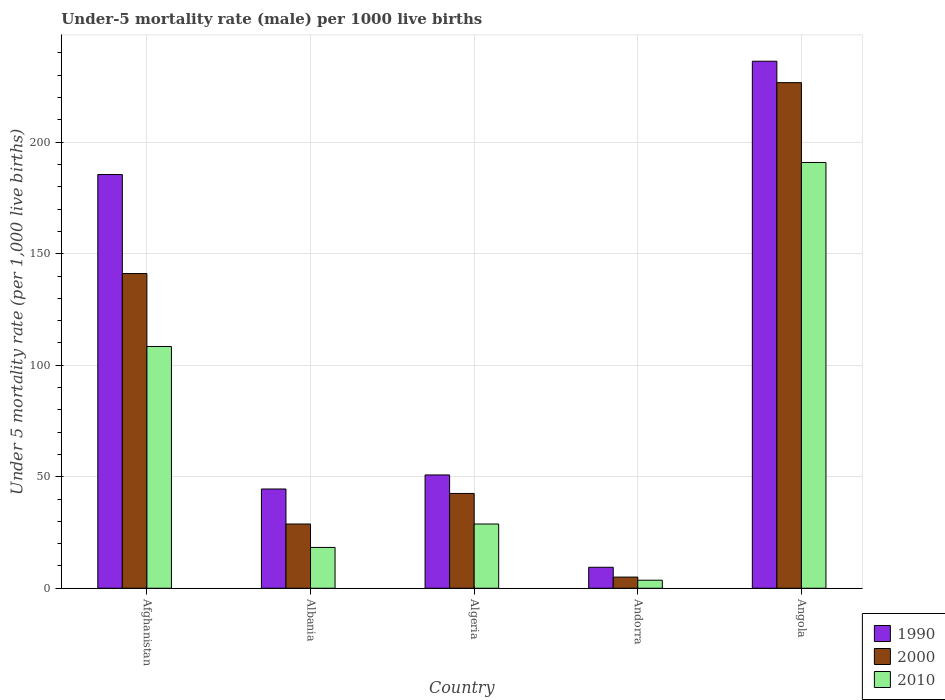How many groups of bars are there?
Offer a very short reply. 5. How many bars are there on the 1st tick from the left?
Provide a succinct answer. 3. How many bars are there on the 1st tick from the right?
Offer a terse response. 3. What is the label of the 4th group of bars from the left?
Provide a short and direct response. Andorra. In how many cases, is the number of bars for a given country not equal to the number of legend labels?
Offer a terse response. 0. What is the under-five mortality rate in 2010 in Albania?
Provide a short and direct response. 18.3. Across all countries, what is the maximum under-five mortality rate in 2010?
Offer a very short reply. 190.9. Across all countries, what is the minimum under-five mortality rate in 2000?
Your answer should be compact. 5. In which country was the under-five mortality rate in 2000 maximum?
Offer a terse response. Angola. In which country was the under-five mortality rate in 2010 minimum?
Your response must be concise. Andorra. What is the total under-five mortality rate in 1990 in the graph?
Your answer should be compact. 526.5. What is the difference between the under-five mortality rate in 1990 in Afghanistan and that in Andorra?
Keep it short and to the point. 176.1. What is the difference between the under-five mortality rate in 1990 in Afghanistan and the under-five mortality rate in 2010 in Algeria?
Give a very brief answer. 156.7. What is the difference between the under-five mortality rate of/in 2000 and under-five mortality rate of/in 1990 in Angola?
Provide a succinct answer. -9.6. What is the ratio of the under-five mortality rate in 2010 in Afghanistan to that in Algeria?
Ensure brevity in your answer.  3.76. Is the under-five mortality rate in 1990 in Afghanistan less than that in Andorra?
Provide a succinct answer. No. What is the difference between the highest and the second highest under-five mortality rate in 2000?
Keep it short and to the point. 184.2. What is the difference between the highest and the lowest under-five mortality rate in 2000?
Keep it short and to the point. 221.7. Is the sum of the under-five mortality rate in 2010 in Albania and Algeria greater than the maximum under-five mortality rate in 1990 across all countries?
Provide a succinct answer. No. What does the 1st bar from the right in Algeria represents?
Ensure brevity in your answer.  2010. How many bars are there?
Your answer should be compact. 15. Are all the bars in the graph horizontal?
Provide a short and direct response. No. Are the values on the major ticks of Y-axis written in scientific E-notation?
Give a very brief answer. No. Does the graph contain any zero values?
Ensure brevity in your answer.  No. Does the graph contain grids?
Your answer should be very brief. Yes. Where does the legend appear in the graph?
Offer a very short reply. Bottom right. How many legend labels are there?
Your answer should be compact. 3. How are the legend labels stacked?
Make the answer very short. Vertical. What is the title of the graph?
Provide a short and direct response. Under-5 mortality rate (male) per 1000 live births. Does "1970" appear as one of the legend labels in the graph?
Make the answer very short. No. What is the label or title of the Y-axis?
Your answer should be very brief. Under 5 mortality rate (per 1,0 live births). What is the Under 5 mortality rate (per 1,000 live births) in 1990 in Afghanistan?
Offer a very short reply. 185.5. What is the Under 5 mortality rate (per 1,000 live births) of 2000 in Afghanistan?
Provide a short and direct response. 141.1. What is the Under 5 mortality rate (per 1,000 live births) in 2010 in Afghanistan?
Give a very brief answer. 108.4. What is the Under 5 mortality rate (per 1,000 live births) in 1990 in Albania?
Make the answer very short. 44.5. What is the Under 5 mortality rate (per 1,000 live births) in 2000 in Albania?
Your answer should be compact. 28.8. What is the Under 5 mortality rate (per 1,000 live births) in 2010 in Albania?
Make the answer very short. 18.3. What is the Under 5 mortality rate (per 1,000 live births) in 1990 in Algeria?
Give a very brief answer. 50.8. What is the Under 5 mortality rate (per 1,000 live births) in 2000 in Algeria?
Offer a very short reply. 42.5. What is the Under 5 mortality rate (per 1,000 live births) in 2010 in Algeria?
Provide a succinct answer. 28.8. What is the Under 5 mortality rate (per 1,000 live births) in 1990 in Andorra?
Your answer should be compact. 9.4. What is the Under 5 mortality rate (per 1,000 live births) in 2010 in Andorra?
Offer a terse response. 3.6. What is the Under 5 mortality rate (per 1,000 live births) in 1990 in Angola?
Provide a short and direct response. 236.3. What is the Under 5 mortality rate (per 1,000 live births) in 2000 in Angola?
Your answer should be very brief. 226.7. What is the Under 5 mortality rate (per 1,000 live births) of 2010 in Angola?
Provide a short and direct response. 190.9. Across all countries, what is the maximum Under 5 mortality rate (per 1,000 live births) in 1990?
Offer a terse response. 236.3. Across all countries, what is the maximum Under 5 mortality rate (per 1,000 live births) of 2000?
Provide a short and direct response. 226.7. Across all countries, what is the maximum Under 5 mortality rate (per 1,000 live births) of 2010?
Your answer should be compact. 190.9. Across all countries, what is the minimum Under 5 mortality rate (per 1,000 live births) of 2010?
Keep it short and to the point. 3.6. What is the total Under 5 mortality rate (per 1,000 live births) of 1990 in the graph?
Ensure brevity in your answer.  526.5. What is the total Under 5 mortality rate (per 1,000 live births) of 2000 in the graph?
Provide a short and direct response. 444.1. What is the total Under 5 mortality rate (per 1,000 live births) in 2010 in the graph?
Your answer should be very brief. 350. What is the difference between the Under 5 mortality rate (per 1,000 live births) of 1990 in Afghanistan and that in Albania?
Ensure brevity in your answer.  141. What is the difference between the Under 5 mortality rate (per 1,000 live births) in 2000 in Afghanistan and that in Albania?
Make the answer very short. 112.3. What is the difference between the Under 5 mortality rate (per 1,000 live births) of 2010 in Afghanistan and that in Albania?
Provide a short and direct response. 90.1. What is the difference between the Under 5 mortality rate (per 1,000 live births) of 1990 in Afghanistan and that in Algeria?
Provide a short and direct response. 134.7. What is the difference between the Under 5 mortality rate (per 1,000 live births) of 2000 in Afghanistan and that in Algeria?
Ensure brevity in your answer.  98.6. What is the difference between the Under 5 mortality rate (per 1,000 live births) in 2010 in Afghanistan and that in Algeria?
Give a very brief answer. 79.6. What is the difference between the Under 5 mortality rate (per 1,000 live births) in 1990 in Afghanistan and that in Andorra?
Ensure brevity in your answer.  176.1. What is the difference between the Under 5 mortality rate (per 1,000 live births) in 2000 in Afghanistan and that in Andorra?
Offer a very short reply. 136.1. What is the difference between the Under 5 mortality rate (per 1,000 live births) of 2010 in Afghanistan and that in Andorra?
Your answer should be very brief. 104.8. What is the difference between the Under 5 mortality rate (per 1,000 live births) of 1990 in Afghanistan and that in Angola?
Offer a very short reply. -50.8. What is the difference between the Under 5 mortality rate (per 1,000 live births) in 2000 in Afghanistan and that in Angola?
Make the answer very short. -85.6. What is the difference between the Under 5 mortality rate (per 1,000 live births) in 2010 in Afghanistan and that in Angola?
Offer a terse response. -82.5. What is the difference between the Under 5 mortality rate (per 1,000 live births) of 1990 in Albania and that in Algeria?
Offer a very short reply. -6.3. What is the difference between the Under 5 mortality rate (per 1,000 live births) in 2000 in Albania and that in Algeria?
Ensure brevity in your answer.  -13.7. What is the difference between the Under 5 mortality rate (per 1,000 live births) of 2010 in Albania and that in Algeria?
Offer a terse response. -10.5. What is the difference between the Under 5 mortality rate (per 1,000 live births) of 1990 in Albania and that in Andorra?
Give a very brief answer. 35.1. What is the difference between the Under 5 mortality rate (per 1,000 live births) of 2000 in Albania and that in Andorra?
Offer a terse response. 23.8. What is the difference between the Under 5 mortality rate (per 1,000 live births) of 2010 in Albania and that in Andorra?
Your response must be concise. 14.7. What is the difference between the Under 5 mortality rate (per 1,000 live births) of 1990 in Albania and that in Angola?
Give a very brief answer. -191.8. What is the difference between the Under 5 mortality rate (per 1,000 live births) of 2000 in Albania and that in Angola?
Give a very brief answer. -197.9. What is the difference between the Under 5 mortality rate (per 1,000 live births) of 2010 in Albania and that in Angola?
Ensure brevity in your answer.  -172.6. What is the difference between the Under 5 mortality rate (per 1,000 live births) of 1990 in Algeria and that in Andorra?
Make the answer very short. 41.4. What is the difference between the Under 5 mortality rate (per 1,000 live births) of 2000 in Algeria and that in Andorra?
Your response must be concise. 37.5. What is the difference between the Under 5 mortality rate (per 1,000 live births) of 2010 in Algeria and that in Andorra?
Provide a short and direct response. 25.2. What is the difference between the Under 5 mortality rate (per 1,000 live births) in 1990 in Algeria and that in Angola?
Your response must be concise. -185.5. What is the difference between the Under 5 mortality rate (per 1,000 live births) in 2000 in Algeria and that in Angola?
Offer a terse response. -184.2. What is the difference between the Under 5 mortality rate (per 1,000 live births) of 2010 in Algeria and that in Angola?
Your answer should be compact. -162.1. What is the difference between the Under 5 mortality rate (per 1,000 live births) of 1990 in Andorra and that in Angola?
Provide a short and direct response. -226.9. What is the difference between the Under 5 mortality rate (per 1,000 live births) of 2000 in Andorra and that in Angola?
Keep it short and to the point. -221.7. What is the difference between the Under 5 mortality rate (per 1,000 live births) in 2010 in Andorra and that in Angola?
Your answer should be compact. -187.3. What is the difference between the Under 5 mortality rate (per 1,000 live births) of 1990 in Afghanistan and the Under 5 mortality rate (per 1,000 live births) of 2000 in Albania?
Ensure brevity in your answer.  156.7. What is the difference between the Under 5 mortality rate (per 1,000 live births) in 1990 in Afghanistan and the Under 5 mortality rate (per 1,000 live births) in 2010 in Albania?
Provide a short and direct response. 167.2. What is the difference between the Under 5 mortality rate (per 1,000 live births) in 2000 in Afghanistan and the Under 5 mortality rate (per 1,000 live births) in 2010 in Albania?
Provide a succinct answer. 122.8. What is the difference between the Under 5 mortality rate (per 1,000 live births) of 1990 in Afghanistan and the Under 5 mortality rate (per 1,000 live births) of 2000 in Algeria?
Provide a short and direct response. 143. What is the difference between the Under 5 mortality rate (per 1,000 live births) in 1990 in Afghanistan and the Under 5 mortality rate (per 1,000 live births) in 2010 in Algeria?
Keep it short and to the point. 156.7. What is the difference between the Under 5 mortality rate (per 1,000 live births) in 2000 in Afghanistan and the Under 5 mortality rate (per 1,000 live births) in 2010 in Algeria?
Your answer should be very brief. 112.3. What is the difference between the Under 5 mortality rate (per 1,000 live births) in 1990 in Afghanistan and the Under 5 mortality rate (per 1,000 live births) in 2000 in Andorra?
Your response must be concise. 180.5. What is the difference between the Under 5 mortality rate (per 1,000 live births) of 1990 in Afghanistan and the Under 5 mortality rate (per 1,000 live births) of 2010 in Andorra?
Provide a succinct answer. 181.9. What is the difference between the Under 5 mortality rate (per 1,000 live births) of 2000 in Afghanistan and the Under 5 mortality rate (per 1,000 live births) of 2010 in Andorra?
Provide a succinct answer. 137.5. What is the difference between the Under 5 mortality rate (per 1,000 live births) in 1990 in Afghanistan and the Under 5 mortality rate (per 1,000 live births) in 2000 in Angola?
Your answer should be very brief. -41.2. What is the difference between the Under 5 mortality rate (per 1,000 live births) of 1990 in Afghanistan and the Under 5 mortality rate (per 1,000 live births) of 2010 in Angola?
Make the answer very short. -5.4. What is the difference between the Under 5 mortality rate (per 1,000 live births) in 2000 in Afghanistan and the Under 5 mortality rate (per 1,000 live births) in 2010 in Angola?
Your response must be concise. -49.8. What is the difference between the Under 5 mortality rate (per 1,000 live births) in 1990 in Albania and the Under 5 mortality rate (per 1,000 live births) in 2010 in Algeria?
Your answer should be very brief. 15.7. What is the difference between the Under 5 mortality rate (per 1,000 live births) of 1990 in Albania and the Under 5 mortality rate (per 1,000 live births) of 2000 in Andorra?
Your response must be concise. 39.5. What is the difference between the Under 5 mortality rate (per 1,000 live births) of 1990 in Albania and the Under 5 mortality rate (per 1,000 live births) of 2010 in Andorra?
Provide a short and direct response. 40.9. What is the difference between the Under 5 mortality rate (per 1,000 live births) of 2000 in Albania and the Under 5 mortality rate (per 1,000 live births) of 2010 in Andorra?
Make the answer very short. 25.2. What is the difference between the Under 5 mortality rate (per 1,000 live births) of 1990 in Albania and the Under 5 mortality rate (per 1,000 live births) of 2000 in Angola?
Offer a very short reply. -182.2. What is the difference between the Under 5 mortality rate (per 1,000 live births) in 1990 in Albania and the Under 5 mortality rate (per 1,000 live births) in 2010 in Angola?
Provide a succinct answer. -146.4. What is the difference between the Under 5 mortality rate (per 1,000 live births) of 2000 in Albania and the Under 5 mortality rate (per 1,000 live births) of 2010 in Angola?
Provide a succinct answer. -162.1. What is the difference between the Under 5 mortality rate (per 1,000 live births) of 1990 in Algeria and the Under 5 mortality rate (per 1,000 live births) of 2000 in Andorra?
Offer a terse response. 45.8. What is the difference between the Under 5 mortality rate (per 1,000 live births) of 1990 in Algeria and the Under 5 mortality rate (per 1,000 live births) of 2010 in Andorra?
Your answer should be compact. 47.2. What is the difference between the Under 5 mortality rate (per 1,000 live births) in 2000 in Algeria and the Under 5 mortality rate (per 1,000 live births) in 2010 in Andorra?
Make the answer very short. 38.9. What is the difference between the Under 5 mortality rate (per 1,000 live births) in 1990 in Algeria and the Under 5 mortality rate (per 1,000 live births) in 2000 in Angola?
Ensure brevity in your answer.  -175.9. What is the difference between the Under 5 mortality rate (per 1,000 live births) in 1990 in Algeria and the Under 5 mortality rate (per 1,000 live births) in 2010 in Angola?
Ensure brevity in your answer.  -140.1. What is the difference between the Under 5 mortality rate (per 1,000 live births) in 2000 in Algeria and the Under 5 mortality rate (per 1,000 live births) in 2010 in Angola?
Your answer should be very brief. -148.4. What is the difference between the Under 5 mortality rate (per 1,000 live births) of 1990 in Andorra and the Under 5 mortality rate (per 1,000 live births) of 2000 in Angola?
Provide a short and direct response. -217.3. What is the difference between the Under 5 mortality rate (per 1,000 live births) of 1990 in Andorra and the Under 5 mortality rate (per 1,000 live births) of 2010 in Angola?
Give a very brief answer. -181.5. What is the difference between the Under 5 mortality rate (per 1,000 live births) in 2000 in Andorra and the Under 5 mortality rate (per 1,000 live births) in 2010 in Angola?
Make the answer very short. -185.9. What is the average Under 5 mortality rate (per 1,000 live births) in 1990 per country?
Your answer should be compact. 105.3. What is the average Under 5 mortality rate (per 1,000 live births) of 2000 per country?
Your answer should be very brief. 88.82. What is the difference between the Under 5 mortality rate (per 1,000 live births) of 1990 and Under 5 mortality rate (per 1,000 live births) of 2000 in Afghanistan?
Provide a short and direct response. 44.4. What is the difference between the Under 5 mortality rate (per 1,000 live births) of 1990 and Under 5 mortality rate (per 1,000 live births) of 2010 in Afghanistan?
Make the answer very short. 77.1. What is the difference between the Under 5 mortality rate (per 1,000 live births) in 2000 and Under 5 mortality rate (per 1,000 live births) in 2010 in Afghanistan?
Keep it short and to the point. 32.7. What is the difference between the Under 5 mortality rate (per 1,000 live births) in 1990 and Under 5 mortality rate (per 1,000 live births) in 2010 in Albania?
Your answer should be very brief. 26.2. What is the difference between the Under 5 mortality rate (per 1,000 live births) in 1990 and Under 5 mortality rate (per 1,000 live births) in 2000 in Algeria?
Keep it short and to the point. 8.3. What is the difference between the Under 5 mortality rate (per 1,000 live births) in 1990 and Under 5 mortality rate (per 1,000 live births) in 2010 in Algeria?
Give a very brief answer. 22. What is the difference between the Under 5 mortality rate (per 1,000 live births) in 1990 and Under 5 mortality rate (per 1,000 live births) in 2000 in Andorra?
Make the answer very short. 4.4. What is the difference between the Under 5 mortality rate (per 1,000 live births) in 2000 and Under 5 mortality rate (per 1,000 live births) in 2010 in Andorra?
Offer a terse response. 1.4. What is the difference between the Under 5 mortality rate (per 1,000 live births) in 1990 and Under 5 mortality rate (per 1,000 live births) in 2000 in Angola?
Ensure brevity in your answer.  9.6. What is the difference between the Under 5 mortality rate (per 1,000 live births) of 1990 and Under 5 mortality rate (per 1,000 live births) of 2010 in Angola?
Keep it short and to the point. 45.4. What is the difference between the Under 5 mortality rate (per 1,000 live births) of 2000 and Under 5 mortality rate (per 1,000 live births) of 2010 in Angola?
Keep it short and to the point. 35.8. What is the ratio of the Under 5 mortality rate (per 1,000 live births) in 1990 in Afghanistan to that in Albania?
Your answer should be very brief. 4.17. What is the ratio of the Under 5 mortality rate (per 1,000 live births) in 2000 in Afghanistan to that in Albania?
Provide a succinct answer. 4.9. What is the ratio of the Under 5 mortality rate (per 1,000 live births) in 2010 in Afghanistan to that in Albania?
Keep it short and to the point. 5.92. What is the ratio of the Under 5 mortality rate (per 1,000 live births) of 1990 in Afghanistan to that in Algeria?
Provide a short and direct response. 3.65. What is the ratio of the Under 5 mortality rate (per 1,000 live births) of 2000 in Afghanistan to that in Algeria?
Your answer should be very brief. 3.32. What is the ratio of the Under 5 mortality rate (per 1,000 live births) in 2010 in Afghanistan to that in Algeria?
Keep it short and to the point. 3.76. What is the ratio of the Under 5 mortality rate (per 1,000 live births) of 1990 in Afghanistan to that in Andorra?
Ensure brevity in your answer.  19.73. What is the ratio of the Under 5 mortality rate (per 1,000 live births) of 2000 in Afghanistan to that in Andorra?
Make the answer very short. 28.22. What is the ratio of the Under 5 mortality rate (per 1,000 live births) of 2010 in Afghanistan to that in Andorra?
Make the answer very short. 30.11. What is the ratio of the Under 5 mortality rate (per 1,000 live births) of 1990 in Afghanistan to that in Angola?
Offer a terse response. 0.79. What is the ratio of the Under 5 mortality rate (per 1,000 live births) of 2000 in Afghanistan to that in Angola?
Provide a succinct answer. 0.62. What is the ratio of the Under 5 mortality rate (per 1,000 live births) of 2010 in Afghanistan to that in Angola?
Give a very brief answer. 0.57. What is the ratio of the Under 5 mortality rate (per 1,000 live births) of 1990 in Albania to that in Algeria?
Provide a short and direct response. 0.88. What is the ratio of the Under 5 mortality rate (per 1,000 live births) of 2000 in Albania to that in Algeria?
Provide a succinct answer. 0.68. What is the ratio of the Under 5 mortality rate (per 1,000 live births) of 2010 in Albania to that in Algeria?
Make the answer very short. 0.64. What is the ratio of the Under 5 mortality rate (per 1,000 live births) of 1990 in Albania to that in Andorra?
Provide a short and direct response. 4.73. What is the ratio of the Under 5 mortality rate (per 1,000 live births) in 2000 in Albania to that in Andorra?
Ensure brevity in your answer.  5.76. What is the ratio of the Under 5 mortality rate (per 1,000 live births) of 2010 in Albania to that in Andorra?
Your answer should be compact. 5.08. What is the ratio of the Under 5 mortality rate (per 1,000 live births) in 1990 in Albania to that in Angola?
Your answer should be compact. 0.19. What is the ratio of the Under 5 mortality rate (per 1,000 live births) in 2000 in Albania to that in Angola?
Your answer should be very brief. 0.13. What is the ratio of the Under 5 mortality rate (per 1,000 live births) of 2010 in Albania to that in Angola?
Provide a succinct answer. 0.1. What is the ratio of the Under 5 mortality rate (per 1,000 live births) of 1990 in Algeria to that in Andorra?
Make the answer very short. 5.4. What is the ratio of the Under 5 mortality rate (per 1,000 live births) of 2010 in Algeria to that in Andorra?
Ensure brevity in your answer.  8. What is the ratio of the Under 5 mortality rate (per 1,000 live births) in 1990 in Algeria to that in Angola?
Ensure brevity in your answer.  0.21. What is the ratio of the Under 5 mortality rate (per 1,000 live births) in 2000 in Algeria to that in Angola?
Your answer should be very brief. 0.19. What is the ratio of the Under 5 mortality rate (per 1,000 live births) of 2010 in Algeria to that in Angola?
Your response must be concise. 0.15. What is the ratio of the Under 5 mortality rate (per 1,000 live births) of 1990 in Andorra to that in Angola?
Keep it short and to the point. 0.04. What is the ratio of the Under 5 mortality rate (per 1,000 live births) in 2000 in Andorra to that in Angola?
Provide a short and direct response. 0.02. What is the ratio of the Under 5 mortality rate (per 1,000 live births) of 2010 in Andorra to that in Angola?
Your answer should be very brief. 0.02. What is the difference between the highest and the second highest Under 5 mortality rate (per 1,000 live births) in 1990?
Keep it short and to the point. 50.8. What is the difference between the highest and the second highest Under 5 mortality rate (per 1,000 live births) in 2000?
Provide a short and direct response. 85.6. What is the difference between the highest and the second highest Under 5 mortality rate (per 1,000 live births) in 2010?
Provide a short and direct response. 82.5. What is the difference between the highest and the lowest Under 5 mortality rate (per 1,000 live births) of 1990?
Provide a succinct answer. 226.9. What is the difference between the highest and the lowest Under 5 mortality rate (per 1,000 live births) of 2000?
Provide a short and direct response. 221.7. What is the difference between the highest and the lowest Under 5 mortality rate (per 1,000 live births) in 2010?
Your answer should be compact. 187.3. 